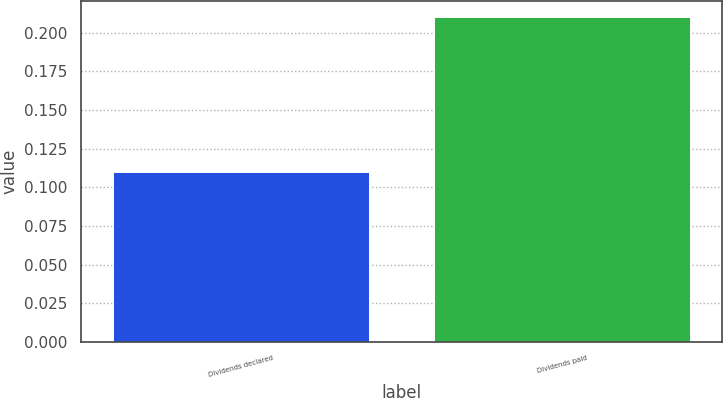<chart> <loc_0><loc_0><loc_500><loc_500><bar_chart><fcel>Dividends declared<fcel>Dividends paid<nl><fcel>0.11<fcel>0.21<nl></chart> 